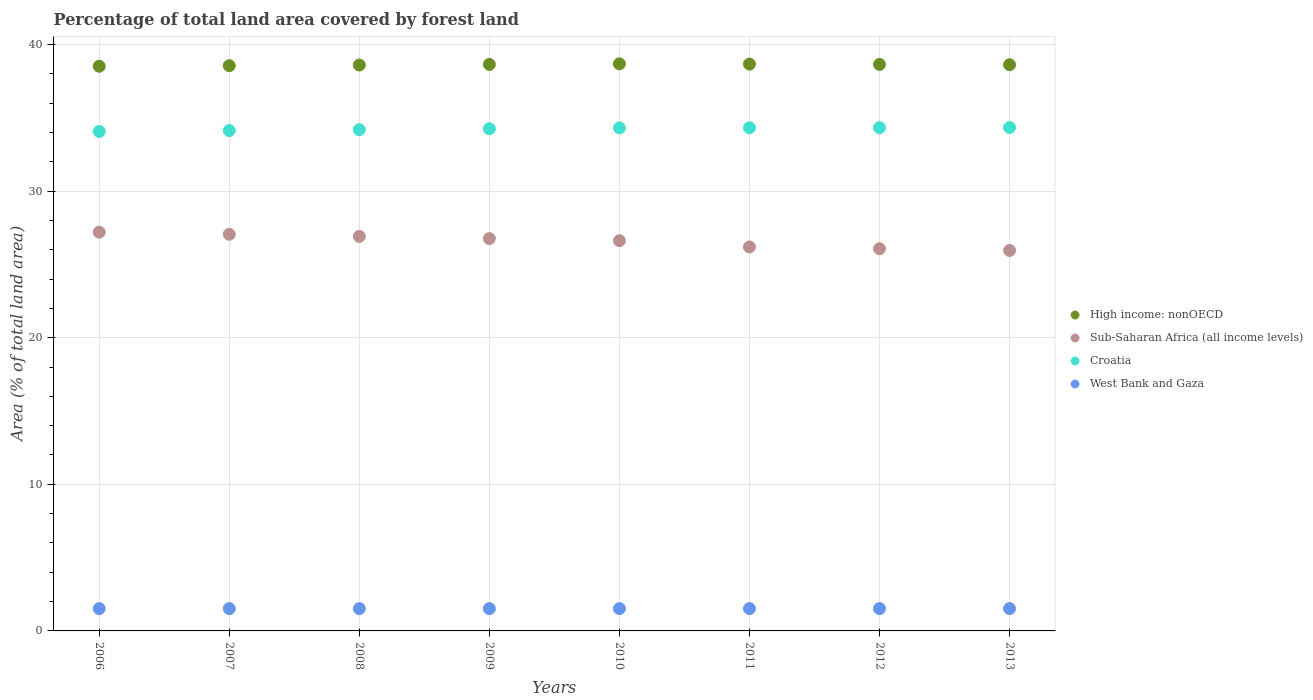How many different coloured dotlines are there?
Provide a short and direct response. 4. Is the number of dotlines equal to the number of legend labels?
Ensure brevity in your answer.  Yes. What is the percentage of forest land in West Bank and Gaza in 2010?
Provide a short and direct response. 1.52. Across all years, what is the maximum percentage of forest land in Sub-Saharan Africa (all income levels)?
Your answer should be compact. 27.2. Across all years, what is the minimum percentage of forest land in West Bank and Gaza?
Provide a succinct answer. 1.52. In which year was the percentage of forest land in West Bank and Gaza minimum?
Your response must be concise. 2006. What is the total percentage of forest land in Sub-Saharan Africa (all income levels) in the graph?
Your answer should be very brief. 212.74. What is the difference between the percentage of forest land in Sub-Saharan Africa (all income levels) in 2009 and that in 2013?
Make the answer very short. 0.81. What is the difference between the percentage of forest land in Croatia in 2011 and the percentage of forest land in Sub-Saharan Africa (all income levels) in 2013?
Provide a succinct answer. 8.37. What is the average percentage of forest land in West Bank and Gaza per year?
Provide a short and direct response. 1.52. In the year 2008, what is the difference between the percentage of forest land in West Bank and Gaza and percentage of forest land in Croatia?
Ensure brevity in your answer.  -32.67. In how many years, is the percentage of forest land in Sub-Saharan Africa (all income levels) greater than 28 %?
Offer a terse response. 0. What is the ratio of the percentage of forest land in High income: nonOECD in 2007 to that in 2013?
Your answer should be compact. 1. Is the difference between the percentage of forest land in West Bank and Gaza in 2009 and 2011 greater than the difference between the percentage of forest land in Croatia in 2009 and 2011?
Your response must be concise. Yes. What is the difference between the highest and the second highest percentage of forest land in Sub-Saharan Africa (all income levels)?
Your response must be concise. 0.15. What is the difference between the highest and the lowest percentage of forest land in High income: nonOECD?
Ensure brevity in your answer.  0.17. In how many years, is the percentage of forest land in Sub-Saharan Africa (all income levels) greater than the average percentage of forest land in Sub-Saharan Africa (all income levels) taken over all years?
Make the answer very short. 5. Is it the case that in every year, the sum of the percentage of forest land in Sub-Saharan Africa (all income levels) and percentage of forest land in Croatia  is greater than the sum of percentage of forest land in High income: nonOECD and percentage of forest land in West Bank and Gaza?
Your answer should be compact. No. Is it the case that in every year, the sum of the percentage of forest land in High income: nonOECD and percentage of forest land in West Bank and Gaza  is greater than the percentage of forest land in Croatia?
Your answer should be compact. Yes. Does the percentage of forest land in Sub-Saharan Africa (all income levels) monotonically increase over the years?
Make the answer very short. No. Is the percentage of forest land in Croatia strictly greater than the percentage of forest land in Sub-Saharan Africa (all income levels) over the years?
Make the answer very short. Yes. Is the percentage of forest land in Croatia strictly less than the percentage of forest land in Sub-Saharan Africa (all income levels) over the years?
Your answer should be very brief. No. What is the difference between two consecutive major ticks on the Y-axis?
Offer a very short reply. 10. Are the values on the major ticks of Y-axis written in scientific E-notation?
Your answer should be compact. No. Does the graph contain grids?
Provide a succinct answer. Yes. Where does the legend appear in the graph?
Your answer should be compact. Center right. How are the legend labels stacked?
Your answer should be very brief. Vertical. What is the title of the graph?
Your response must be concise. Percentage of total land area covered by forest land. What is the label or title of the X-axis?
Offer a very short reply. Years. What is the label or title of the Y-axis?
Your answer should be compact. Area (% of total land area). What is the Area (% of total land area) in High income: nonOECD in 2006?
Your answer should be compact. 38.51. What is the Area (% of total land area) in Sub-Saharan Africa (all income levels) in 2006?
Your answer should be compact. 27.2. What is the Area (% of total land area) of Croatia in 2006?
Make the answer very short. 34.07. What is the Area (% of total land area) in West Bank and Gaza in 2006?
Give a very brief answer. 1.52. What is the Area (% of total land area) of High income: nonOECD in 2007?
Your answer should be compact. 38.55. What is the Area (% of total land area) in Sub-Saharan Africa (all income levels) in 2007?
Keep it short and to the point. 27.05. What is the Area (% of total land area) of Croatia in 2007?
Your answer should be compact. 34.13. What is the Area (% of total land area) in West Bank and Gaza in 2007?
Give a very brief answer. 1.52. What is the Area (% of total land area) of High income: nonOECD in 2008?
Ensure brevity in your answer.  38.6. What is the Area (% of total land area) of Sub-Saharan Africa (all income levels) in 2008?
Your answer should be very brief. 26.91. What is the Area (% of total land area) in Croatia in 2008?
Give a very brief answer. 34.19. What is the Area (% of total land area) of West Bank and Gaza in 2008?
Keep it short and to the point. 1.52. What is the Area (% of total land area) in High income: nonOECD in 2009?
Ensure brevity in your answer.  38.64. What is the Area (% of total land area) in Sub-Saharan Africa (all income levels) in 2009?
Your response must be concise. 26.76. What is the Area (% of total land area) of Croatia in 2009?
Offer a very short reply. 34.25. What is the Area (% of total land area) in West Bank and Gaza in 2009?
Your response must be concise. 1.52. What is the Area (% of total land area) in High income: nonOECD in 2010?
Your answer should be compact. 38.68. What is the Area (% of total land area) of Sub-Saharan Africa (all income levels) in 2010?
Offer a very short reply. 26.62. What is the Area (% of total land area) of Croatia in 2010?
Offer a very short reply. 34.31. What is the Area (% of total land area) of West Bank and Gaza in 2010?
Offer a very short reply. 1.52. What is the Area (% of total land area) in High income: nonOECD in 2011?
Provide a succinct answer. 38.66. What is the Area (% of total land area) of Sub-Saharan Africa (all income levels) in 2011?
Ensure brevity in your answer.  26.19. What is the Area (% of total land area) of Croatia in 2011?
Provide a succinct answer. 34.32. What is the Area (% of total land area) of West Bank and Gaza in 2011?
Provide a short and direct response. 1.52. What is the Area (% of total land area) in High income: nonOECD in 2012?
Offer a very short reply. 38.64. What is the Area (% of total land area) in Sub-Saharan Africa (all income levels) in 2012?
Your response must be concise. 26.07. What is the Area (% of total land area) in Croatia in 2012?
Ensure brevity in your answer.  34.32. What is the Area (% of total land area) of West Bank and Gaza in 2012?
Your answer should be very brief. 1.52. What is the Area (% of total land area) of High income: nonOECD in 2013?
Provide a short and direct response. 38.62. What is the Area (% of total land area) of Sub-Saharan Africa (all income levels) in 2013?
Provide a short and direct response. 25.95. What is the Area (% of total land area) in Croatia in 2013?
Provide a short and direct response. 34.33. What is the Area (% of total land area) of West Bank and Gaza in 2013?
Keep it short and to the point. 1.52. Across all years, what is the maximum Area (% of total land area) of High income: nonOECD?
Give a very brief answer. 38.68. Across all years, what is the maximum Area (% of total land area) of Sub-Saharan Africa (all income levels)?
Your answer should be very brief. 27.2. Across all years, what is the maximum Area (% of total land area) of Croatia?
Your answer should be compact. 34.33. Across all years, what is the maximum Area (% of total land area) of West Bank and Gaza?
Offer a terse response. 1.52. Across all years, what is the minimum Area (% of total land area) in High income: nonOECD?
Offer a very short reply. 38.51. Across all years, what is the minimum Area (% of total land area) of Sub-Saharan Africa (all income levels)?
Give a very brief answer. 25.95. Across all years, what is the minimum Area (% of total land area) in Croatia?
Offer a terse response. 34.07. Across all years, what is the minimum Area (% of total land area) of West Bank and Gaza?
Keep it short and to the point. 1.52. What is the total Area (% of total land area) of High income: nonOECD in the graph?
Provide a short and direct response. 308.9. What is the total Area (% of total land area) in Sub-Saharan Africa (all income levels) in the graph?
Your answer should be compact. 212.74. What is the total Area (% of total land area) of Croatia in the graph?
Ensure brevity in your answer.  273.92. What is the total Area (% of total land area) of West Bank and Gaza in the graph?
Your answer should be very brief. 12.19. What is the difference between the Area (% of total land area) of High income: nonOECD in 2006 and that in 2007?
Ensure brevity in your answer.  -0.04. What is the difference between the Area (% of total land area) in Sub-Saharan Africa (all income levels) in 2006 and that in 2007?
Your response must be concise. 0.15. What is the difference between the Area (% of total land area) in Croatia in 2006 and that in 2007?
Your answer should be compact. -0.06. What is the difference between the Area (% of total land area) of West Bank and Gaza in 2006 and that in 2007?
Offer a terse response. 0. What is the difference between the Area (% of total land area) in High income: nonOECD in 2006 and that in 2008?
Give a very brief answer. -0.08. What is the difference between the Area (% of total land area) in Sub-Saharan Africa (all income levels) in 2006 and that in 2008?
Give a very brief answer. 0.29. What is the difference between the Area (% of total land area) of Croatia in 2006 and that in 2008?
Your answer should be very brief. -0.12. What is the difference between the Area (% of total land area) in High income: nonOECD in 2006 and that in 2009?
Keep it short and to the point. -0.13. What is the difference between the Area (% of total land area) in Sub-Saharan Africa (all income levels) in 2006 and that in 2009?
Ensure brevity in your answer.  0.44. What is the difference between the Area (% of total land area) in Croatia in 2006 and that in 2009?
Offer a terse response. -0.18. What is the difference between the Area (% of total land area) of West Bank and Gaza in 2006 and that in 2009?
Your response must be concise. 0. What is the difference between the Area (% of total land area) of High income: nonOECD in 2006 and that in 2010?
Provide a short and direct response. -0.17. What is the difference between the Area (% of total land area) in Sub-Saharan Africa (all income levels) in 2006 and that in 2010?
Keep it short and to the point. 0.58. What is the difference between the Area (% of total land area) of Croatia in 2006 and that in 2010?
Make the answer very short. -0.24. What is the difference between the Area (% of total land area) of West Bank and Gaza in 2006 and that in 2010?
Your response must be concise. 0. What is the difference between the Area (% of total land area) in High income: nonOECD in 2006 and that in 2011?
Provide a succinct answer. -0.15. What is the difference between the Area (% of total land area) of Croatia in 2006 and that in 2011?
Offer a terse response. -0.25. What is the difference between the Area (% of total land area) in High income: nonOECD in 2006 and that in 2012?
Offer a terse response. -0.13. What is the difference between the Area (% of total land area) in Sub-Saharan Africa (all income levels) in 2006 and that in 2012?
Offer a very short reply. 1.13. What is the difference between the Area (% of total land area) in Croatia in 2006 and that in 2012?
Offer a very short reply. -0.26. What is the difference between the Area (% of total land area) in West Bank and Gaza in 2006 and that in 2012?
Your response must be concise. 0. What is the difference between the Area (% of total land area) in High income: nonOECD in 2006 and that in 2013?
Your answer should be very brief. -0.11. What is the difference between the Area (% of total land area) of Sub-Saharan Africa (all income levels) in 2006 and that in 2013?
Your response must be concise. 1.25. What is the difference between the Area (% of total land area) in Croatia in 2006 and that in 2013?
Offer a terse response. -0.26. What is the difference between the Area (% of total land area) in West Bank and Gaza in 2006 and that in 2013?
Provide a short and direct response. 0. What is the difference between the Area (% of total land area) in High income: nonOECD in 2007 and that in 2008?
Give a very brief answer. -0.04. What is the difference between the Area (% of total land area) of Sub-Saharan Africa (all income levels) in 2007 and that in 2008?
Your answer should be compact. 0.15. What is the difference between the Area (% of total land area) in Croatia in 2007 and that in 2008?
Give a very brief answer. -0.06. What is the difference between the Area (% of total land area) in High income: nonOECD in 2007 and that in 2009?
Provide a succinct answer. -0.08. What is the difference between the Area (% of total land area) in Sub-Saharan Africa (all income levels) in 2007 and that in 2009?
Ensure brevity in your answer.  0.29. What is the difference between the Area (% of total land area) of Croatia in 2007 and that in 2009?
Offer a terse response. -0.12. What is the difference between the Area (% of total land area) of High income: nonOECD in 2007 and that in 2010?
Ensure brevity in your answer.  -0.13. What is the difference between the Area (% of total land area) in Sub-Saharan Africa (all income levels) in 2007 and that in 2010?
Provide a succinct answer. 0.44. What is the difference between the Area (% of total land area) in Croatia in 2007 and that in 2010?
Provide a short and direct response. -0.18. What is the difference between the Area (% of total land area) in High income: nonOECD in 2007 and that in 2011?
Offer a terse response. -0.11. What is the difference between the Area (% of total land area) in Sub-Saharan Africa (all income levels) in 2007 and that in 2011?
Your response must be concise. 0.86. What is the difference between the Area (% of total land area) of Croatia in 2007 and that in 2011?
Your response must be concise. -0.19. What is the difference between the Area (% of total land area) in West Bank and Gaza in 2007 and that in 2011?
Your answer should be compact. 0. What is the difference between the Area (% of total land area) of High income: nonOECD in 2007 and that in 2012?
Ensure brevity in your answer.  -0.08. What is the difference between the Area (% of total land area) in Sub-Saharan Africa (all income levels) in 2007 and that in 2012?
Your answer should be compact. 0.98. What is the difference between the Area (% of total land area) in Croatia in 2007 and that in 2012?
Ensure brevity in your answer.  -0.2. What is the difference between the Area (% of total land area) in High income: nonOECD in 2007 and that in 2013?
Your answer should be compact. -0.06. What is the difference between the Area (% of total land area) in Sub-Saharan Africa (all income levels) in 2007 and that in 2013?
Make the answer very short. 1.1. What is the difference between the Area (% of total land area) of Croatia in 2007 and that in 2013?
Your response must be concise. -0.2. What is the difference between the Area (% of total land area) of High income: nonOECD in 2008 and that in 2009?
Keep it short and to the point. -0.04. What is the difference between the Area (% of total land area) of Sub-Saharan Africa (all income levels) in 2008 and that in 2009?
Give a very brief answer. 0.15. What is the difference between the Area (% of total land area) in Croatia in 2008 and that in 2009?
Provide a short and direct response. -0.06. What is the difference between the Area (% of total land area) in West Bank and Gaza in 2008 and that in 2009?
Offer a terse response. 0. What is the difference between the Area (% of total land area) of High income: nonOECD in 2008 and that in 2010?
Provide a succinct answer. -0.08. What is the difference between the Area (% of total land area) of Sub-Saharan Africa (all income levels) in 2008 and that in 2010?
Make the answer very short. 0.29. What is the difference between the Area (% of total land area) in Croatia in 2008 and that in 2010?
Make the answer very short. -0.12. What is the difference between the Area (% of total land area) of High income: nonOECD in 2008 and that in 2011?
Offer a very short reply. -0.06. What is the difference between the Area (% of total land area) of Sub-Saharan Africa (all income levels) in 2008 and that in 2011?
Make the answer very short. 0.71. What is the difference between the Area (% of total land area) in Croatia in 2008 and that in 2011?
Provide a short and direct response. -0.13. What is the difference between the Area (% of total land area) in West Bank and Gaza in 2008 and that in 2011?
Offer a terse response. 0. What is the difference between the Area (% of total land area) of High income: nonOECD in 2008 and that in 2012?
Provide a succinct answer. -0.04. What is the difference between the Area (% of total land area) of Sub-Saharan Africa (all income levels) in 2008 and that in 2012?
Your response must be concise. 0.84. What is the difference between the Area (% of total land area) of Croatia in 2008 and that in 2012?
Offer a terse response. -0.14. What is the difference between the Area (% of total land area) in High income: nonOECD in 2008 and that in 2013?
Give a very brief answer. -0.02. What is the difference between the Area (% of total land area) in Sub-Saharan Africa (all income levels) in 2008 and that in 2013?
Offer a terse response. 0.96. What is the difference between the Area (% of total land area) in Croatia in 2008 and that in 2013?
Provide a short and direct response. -0.14. What is the difference between the Area (% of total land area) in West Bank and Gaza in 2008 and that in 2013?
Make the answer very short. 0. What is the difference between the Area (% of total land area) of High income: nonOECD in 2009 and that in 2010?
Your response must be concise. -0.04. What is the difference between the Area (% of total land area) of Sub-Saharan Africa (all income levels) in 2009 and that in 2010?
Keep it short and to the point. 0.15. What is the difference between the Area (% of total land area) of Croatia in 2009 and that in 2010?
Your answer should be compact. -0.06. What is the difference between the Area (% of total land area) of High income: nonOECD in 2009 and that in 2011?
Your answer should be compact. -0.02. What is the difference between the Area (% of total land area) in Sub-Saharan Africa (all income levels) in 2009 and that in 2011?
Provide a short and direct response. 0.57. What is the difference between the Area (% of total land area) in Croatia in 2009 and that in 2011?
Ensure brevity in your answer.  -0.07. What is the difference between the Area (% of total land area) in High income: nonOECD in 2009 and that in 2012?
Your response must be concise. -0. What is the difference between the Area (% of total land area) in Sub-Saharan Africa (all income levels) in 2009 and that in 2012?
Give a very brief answer. 0.69. What is the difference between the Area (% of total land area) in Croatia in 2009 and that in 2012?
Provide a succinct answer. -0.08. What is the difference between the Area (% of total land area) in High income: nonOECD in 2009 and that in 2013?
Give a very brief answer. 0.02. What is the difference between the Area (% of total land area) in Sub-Saharan Africa (all income levels) in 2009 and that in 2013?
Offer a very short reply. 0.81. What is the difference between the Area (% of total land area) in Croatia in 2009 and that in 2013?
Your answer should be compact. -0.08. What is the difference between the Area (% of total land area) of High income: nonOECD in 2010 and that in 2011?
Your response must be concise. 0.02. What is the difference between the Area (% of total land area) in Sub-Saharan Africa (all income levels) in 2010 and that in 2011?
Ensure brevity in your answer.  0.42. What is the difference between the Area (% of total land area) in Croatia in 2010 and that in 2011?
Make the answer very short. -0.01. What is the difference between the Area (% of total land area) of High income: nonOECD in 2010 and that in 2012?
Your answer should be compact. 0.04. What is the difference between the Area (% of total land area) in Sub-Saharan Africa (all income levels) in 2010 and that in 2012?
Your answer should be compact. 0.54. What is the difference between the Area (% of total land area) of Croatia in 2010 and that in 2012?
Give a very brief answer. -0.01. What is the difference between the Area (% of total land area) in High income: nonOECD in 2010 and that in 2013?
Offer a terse response. 0.06. What is the difference between the Area (% of total land area) in Sub-Saharan Africa (all income levels) in 2010 and that in 2013?
Provide a succinct answer. 0.66. What is the difference between the Area (% of total land area) in Croatia in 2010 and that in 2013?
Offer a very short reply. -0.02. What is the difference between the Area (% of total land area) of West Bank and Gaza in 2010 and that in 2013?
Your response must be concise. 0. What is the difference between the Area (% of total land area) in High income: nonOECD in 2011 and that in 2012?
Your answer should be very brief. 0.02. What is the difference between the Area (% of total land area) of Sub-Saharan Africa (all income levels) in 2011 and that in 2012?
Provide a succinct answer. 0.12. What is the difference between the Area (% of total land area) in Croatia in 2011 and that in 2012?
Your answer should be compact. -0.01. What is the difference between the Area (% of total land area) of High income: nonOECD in 2011 and that in 2013?
Provide a short and direct response. 0.04. What is the difference between the Area (% of total land area) of Sub-Saharan Africa (all income levels) in 2011 and that in 2013?
Give a very brief answer. 0.24. What is the difference between the Area (% of total land area) in Croatia in 2011 and that in 2013?
Give a very brief answer. -0.01. What is the difference between the Area (% of total land area) of High income: nonOECD in 2012 and that in 2013?
Your response must be concise. 0.02. What is the difference between the Area (% of total land area) of Sub-Saharan Africa (all income levels) in 2012 and that in 2013?
Ensure brevity in your answer.  0.12. What is the difference between the Area (% of total land area) of Croatia in 2012 and that in 2013?
Ensure brevity in your answer.  -0.01. What is the difference between the Area (% of total land area) of West Bank and Gaza in 2012 and that in 2013?
Make the answer very short. 0. What is the difference between the Area (% of total land area) in High income: nonOECD in 2006 and the Area (% of total land area) in Sub-Saharan Africa (all income levels) in 2007?
Provide a short and direct response. 11.46. What is the difference between the Area (% of total land area) in High income: nonOECD in 2006 and the Area (% of total land area) in Croatia in 2007?
Make the answer very short. 4.39. What is the difference between the Area (% of total land area) of High income: nonOECD in 2006 and the Area (% of total land area) of West Bank and Gaza in 2007?
Offer a very short reply. 36.99. What is the difference between the Area (% of total land area) of Sub-Saharan Africa (all income levels) in 2006 and the Area (% of total land area) of Croatia in 2007?
Offer a terse response. -6.93. What is the difference between the Area (% of total land area) in Sub-Saharan Africa (all income levels) in 2006 and the Area (% of total land area) in West Bank and Gaza in 2007?
Offer a terse response. 25.67. What is the difference between the Area (% of total land area) of Croatia in 2006 and the Area (% of total land area) of West Bank and Gaza in 2007?
Your answer should be very brief. 32.54. What is the difference between the Area (% of total land area) of High income: nonOECD in 2006 and the Area (% of total land area) of Sub-Saharan Africa (all income levels) in 2008?
Your response must be concise. 11.61. What is the difference between the Area (% of total land area) of High income: nonOECD in 2006 and the Area (% of total land area) of Croatia in 2008?
Your answer should be very brief. 4.32. What is the difference between the Area (% of total land area) of High income: nonOECD in 2006 and the Area (% of total land area) of West Bank and Gaza in 2008?
Offer a very short reply. 36.99. What is the difference between the Area (% of total land area) of Sub-Saharan Africa (all income levels) in 2006 and the Area (% of total land area) of Croatia in 2008?
Give a very brief answer. -6.99. What is the difference between the Area (% of total land area) in Sub-Saharan Africa (all income levels) in 2006 and the Area (% of total land area) in West Bank and Gaza in 2008?
Make the answer very short. 25.67. What is the difference between the Area (% of total land area) of Croatia in 2006 and the Area (% of total land area) of West Bank and Gaza in 2008?
Provide a succinct answer. 32.54. What is the difference between the Area (% of total land area) of High income: nonOECD in 2006 and the Area (% of total land area) of Sub-Saharan Africa (all income levels) in 2009?
Offer a very short reply. 11.75. What is the difference between the Area (% of total land area) in High income: nonOECD in 2006 and the Area (% of total land area) in Croatia in 2009?
Keep it short and to the point. 4.26. What is the difference between the Area (% of total land area) of High income: nonOECD in 2006 and the Area (% of total land area) of West Bank and Gaza in 2009?
Ensure brevity in your answer.  36.99. What is the difference between the Area (% of total land area) in Sub-Saharan Africa (all income levels) in 2006 and the Area (% of total land area) in Croatia in 2009?
Give a very brief answer. -7.05. What is the difference between the Area (% of total land area) in Sub-Saharan Africa (all income levels) in 2006 and the Area (% of total land area) in West Bank and Gaza in 2009?
Offer a very short reply. 25.67. What is the difference between the Area (% of total land area) in Croatia in 2006 and the Area (% of total land area) in West Bank and Gaza in 2009?
Provide a succinct answer. 32.54. What is the difference between the Area (% of total land area) of High income: nonOECD in 2006 and the Area (% of total land area) of Sub-Saharan Africa (all income levels) in 2010?
Your response must be concise. 11.9. What is the difference between the Area (% of total land area) in High income: nonOECD in 2006 and the Area (% of total land area) in Croatia in 2010?
Your response must be concise. 4.2. What is the difference between the Area (% of total land area) of High income: nonOECD in 2006 and the Area (% of total land area) of West Bank and Gaza in 2010?
Provide a short and direct response. 36.99. What is the difference between the Area (% of total land area) in Sub-Saharan Africa (all income levels) in 2006 and the Area (% of total land area) in Croatia in 2010?
Your response must be concise. -7.11. What is the difference between the Area (% of total land area) in Sub-Saharan Africa (all income levels) in 2006 and the Area (% of total land area) in West Bank and Gaza in 2010?
Provide a succinct answer. 25.67. What is the difference between the Area (% of total land area) in Croatia in 2006 and the Area (% of total land area) in West Bank and Gaza in 2010?
Provide a short and direct response. 32.54. What is the difference between the Area (% of total land area) in High income: nonOECD in 2006 and the Area (% of total land area) in Sub-Saharan Africa (all income levels) in 2011?
Give a very brief answer. 12.32. What is the difference between the Area (% of total land area) in High income: nonOECD in 2006 and the Area (% of total land area) in Croatia in 2011?
Your answer should be compact. 4.2. What is the difference between the Area (% of total land area) in High income: nonOECD in 2006 and the Area (% of total land area) in West Bank and Gaza in 2011?
Make the answer very short. 36.99. What is the difference between the Area (% of total land area) in Sub-Saharan Africa (all income levels) in 2006 and the Area (% of total land area) in Croatia in 2011?
Give a very brief answer. -7.12. What is the difference between the Area (% of total land area) of Sub-Saharan Africa (all income levels) in 2006 and the Area (% of total land area) of West Bank and Gaza in 2011?
Your answer should be very brief. 25.67. What is the difference between the Area (% of total land area) in Croatia in 2006 and the Area (% of total land area) in West Bank and Gaza in 2011?
Provide a succinct answer. 32.54. What is the difference between the Area (% of total land area) of High income: nonOECD in 2006 and the Area (% of total land area) of Sub-Saharan Africa (all income levels) in 2012?
Keep it short and to the point. 12.44. What is the difference between the Area (% of total land area) of High income: nonOECD in 2006 and the Area (% of total land area) of Croatia in 2012?
Ensure brevity in your answer.  4.19. What is the difference between the Area (% of total land area) in High income: nonOECD in 2006 and the Area (% of total land area) in West Bank and Gaza in 2012?
Your response must be concise. 36.99. What is the difference between the Area (% of total land area) in Sub-Saharan Africa (all income levels) in 2006 and the Area (% of total land area) in Croatia in 2012?
Offer a very short reply. -7.13. What is the difference between the Area (% of total land area) in Sub-Saharan Africa (all income levels) in 2006 and the Area (% of total land area) in West Bank and Gaza in 2012?
Ensure brevity in your answer.  25.67. What is the difference between the Area (% of total land area) in Croatia in 2006 and the Area (% of total land area) in West Bank and Gaza in 2012?
Offer a terse response. 32.54. What is the difference between the Area (% of total land area) in High income: nonOECD in 2006 and the Area (% of total land area) in Sub-Saharan Africa (all income levels) in 2013?
Ensure brevity in your answer.  12.56. What is the difference between the Area (% of total land area) in High income: nonOECD in 2006 and the Area (% of total land area) in Croatia in 2013?
Ensure brevity in your answer.  4.18. What is the difference between the Area (% of total land area) in High income: nonOECD in 2006 and the Area (% of total land area) in West Bank and Gaza in 2013?
Offer a very short reply. 36.99. What is the difference between the Area (% of total land area) in Sub-Saharan Africa (all income levels) in 2006 and the Area (% of total land area) in Croatia in 2013?
Your answer should be compact. -7.14. What is the difference between the Area (% of total land area) in Sub-Saharan Africa (all income levels) in 2006 and the Area (% of total land area) in West Bank and Gaza in 2013?
Make the answer very short. 25.67. What is the difference between the Area (% of total land area) in Croatia in 2006 and the Area (% of total land area) in West Bank and Gaza in 2013?
Offer a terse response. 32.54. What is the difference between the Area (% of total land area) of High income: nonOECD in 2007 and the Area (% of total land area) of Sub-Saharan Africa (all income levels) in 2008?
Your answer should be very brief. 11.65. What is the difference between the Area (% of total land area) of High income: nonOECD in 2007 and the Area (% of total land area) of Croatia in 2008?
Your answer should be compact. 4.37. What is the difference between the Area (% of total land area) in High income: nonOECD in 2007 and the Area (% of total land area) in West Bank and Gaza in 2008?
Provide a succinct answer. 37.03. What is the difference between the Area (% of total land area) of Sub-Saharan Africa (all income levels) in 2007 and the Area (% of total land area) of Croatia in 2008?
Make the answer very short. -7.14. What is the difference between the Area (% of total land area) of Sub-Saharan Africa (all income levels) in 2007 and the Area (% of total land area) of West Bank and Gaza in 2008?
Your response must be concise. 25.53. What is the difference between the Area (% of total land area) in Croatia in 2007 and the Area (% of total land area) in West Bank and Gaza in 2008?
Ensure brevity in your answer.  32.6. What is the difference between the Area (% of total land area) in High income: nonOECD in 2007 and the Area (% of total land area) in Sub-Saharan Africa (all income levels) in 2009?
Your answer should be very brief. 11.79. What is the difference between the Area (% of total land area) in High income: nonOECD in 2007 and the Area (% of total land area) in Croatia in 2009?
Offer a very short reply. 4.31. What is the difference between the Area (% of total land area) in High income: nonOECD in 2007 and the Area (% of total land area) in West Bank and Gaza in 2009?
Make the answer very short. 37.03. What is the difference between the Area (% of total land area) of Sub-Saharan Africa (all income levels) in 2007 and the Area (% of total land area) of Croatia in 2009?
Your response must be concise. -7.2. What is the difference between the Area (% of total land area) in Sub-Saharan Africa (all income levels) in 2007 and the Area (% of total land area) in West Bank and Gaza in 2009?
Your response must be concise. 25.53. What is the difference between the Area (% of total land area) of Croatia in 2007 and the Area (% of total land area) of West Bank and Gaza in 2009?
Your answer should be compact. 32.6. What is the difference between the Area (% of total land area) in High income: nonOECD in 2007 and the Area (% of total land area) in Sub-Saharan Africa (all income levels) in 2010?
Provide a short and direct response. 11.94. What is the difference between the Area (% of total land area) in High income: nonOECD in 2007 and the Area (% of total land area) in Croatia in 2010?
Your response must be concise. 4.24. What is the difference between the Area (% of total land area) of High income: nonOECD in 2007 and the Area (% of total land area) of West Bank and Gaza in 2010?
Your answer should be very brief. 37.03. What is the difference between the Area (% of total land area) of Sub-Saharan Africa (all income levels) in 2007 and the Area (% of total land area) of Croatia in 2010?
Offer a terse response. -7.26. What is the difference between the Area (% of total land area) of Sub-Saharan Africa (all income levels) in 2007 and the Area (% of total land area) of West Bank and Gaza in 2010?
Offer a very short reply. 25.53. What is the difference between the Area (% of total land area) in Croatia in 2007 and the Area (% of total land area) in West Bank and Gaza in 2010?
Offer a very short reply. 32.6. What is the difference between the Area (% of total land area) of High income: nonOECD in 2007 and the Area (% of total land area) of Sub-Saharan Africa (all income levels) in 2011?
Ensure brevity in your answer.  12.36. What is the difference between the Area (% of total land area) in High income: nonOECD in 2007 and the Area (% of total land area) in Croatia in 2011?
Your answer should be compact. 4.24. What is the difference between the Area (% of total land area) in High income: nonOECD in 2007 and the Area (% of total land area) in West Bank and Gaza in 2011?
Make the answer very short. 37.03. What is the difference between the Area (% of total land area) in Sub-Saharan Africa (all income levels) in 2007 and the Area (% of total land area) in Croatia in 2011?
Give a very brief answer. -7.27. What is the difference between the Area (% of total land area) of Sub-Saharan Africa (all income levels) in 2007 and the Area (% of total land area) of West Bank and Gaza in 2011?
Your answer should be very brief. 25.53. What is the difference between the Area (% of total land area) of Croatia in 2007 and the Area (% of total land area) of West Bank and Gaza in 2011?
Offer a terse response. 32.6. What is the difference between the Area (% of total land area) in High income: nonOECD in 2007 and the Area (% of total land area) in Sub-Saharan Africa (all income levels) in 2012?
Ensure brevity in your answer.  12.48. What is the difference between the Area (% of total land area) of High income: nonOECD in 2007 and the Area (% of total land area) of Croatia in 2012?
Offer a very short reply. 4.23. What is the difference between the Area (% of total land area) in High income: nonOECD in 2007 and the Area (% of total land area) in West Bank and Gaza in 2012?
Your response must be concise. 37.03. What is the difference between the Area (% of total land area) in Sub-Saharan Africa (all income levels) in 2007 and the Area (% of total land area) in Croatia in 2012?
Make the answer very short. -7.27. What is the difference between the Area (% of total land area) in Sub-Saharan Africa (all income levels) in 2007 and the Area (% of total land area) in West Bank and Gaza in 2012?
Ensure brevity in your answer.  25.53. What is the difference between the Area (% of total land area) of Croatia in 2007 and the Area (% of total land area) of West Bank and Gaza in 2012?
Provide a short and direct response. 32.6. What is the difference between the Area (% of total land area) in High income: nonOECD in 2007 and the Area (% of total land area) in Sub-Saharan Africa (all income levels) in 2013?
Make the answer very short. 12.6. What is the difference between the Area (% of total land area) of High income: nonOECD in 2007 and the Area (% of total land area) of Croatia in 2013?
Provide a succinct answer. 4.22. What is the difference between the Area (% of total land area) in High income: nonOECD in 2007 and the Area (% of total land area) in West Bank and Gaza in 2013?
Ensure brevity in your answer.  37.03. What is the difference between the Area (% of total land area) of Sub-Saharan Africa (all income levels) in 2007 and the Area (% of total land area) of Croatia in 2013?
Keep it short and to the point. -7.28. What is the difference between the Area (% of total land area) in Sub-Saharan Africa (all income levels) in 2007 and the Area (% of total land area) in West Bank and Gaza in 2013?
Your answer should be very brief. 25.53. What is the difference between the Area (% of total land area) in Croatia in 2007 and the Area (% of total land area) in West Bank and Gaza in 2013?
Ensure brevity in your answer.  32.6. What is the difference between the Area (% of total land area) of High income: nonOECD in 2008 and the Area (% of total land area) of Sub-Saharan Africa (all income levels) in 2009?
Provide a succinct answer. 11.84. What is the difference between the Area (% of total land area) of High income: nonOECD in 2008 and the Area (% of total land area) of Croatia in 2009?
Give a very brief answer. 4.35. What is the difference between the Area (% of total land area) of High income: nonOECD in 2008 and the Area (% of total land area) of West Bank and Gaza in 2009?
Offer a terse response. 37.07. What is the difference between the Area (% of total land area) of Sub-Saharan Africa (all income levels) in 2008 and the Area (% of total land area) of Croatia in 2009?
Your answer should be compact. -7.34. What is the difference between the Area (% of total land area) in Sub-Saharan Africa (all income levels) in 2008 and the Area (% of total land area) in West Bank and Gaza in 2009?
Provide a short and direct response. 25.38. What is the difference between the Area (% of total land area) in Croatia in 2008 and the Area (% of total land area) in West Bank and Gaza in 2009?
Offer a very short reply. 32.67. What is the difference between the Area (% of total land area) in High income: nonOECD in 2008 and the Area (% of total land area) in Sub-Saharan Africa (all income levels) in 2010?
Your answer should be very brief. 11.98. What is the difference between the Area (% of total land area) in High income: nonOECD in 2008 and the Area (% of total land area) in Croatia in 2010?
Your answer should be compact. 4.29. What is the difference between the Area (% of total land area) in High income: nonOECD in 2008 and the Area (% of total land area) in West Bank and Gaza in 2010?
Your answer should be compact. 37.07. What is the difference between the Area (% of total land area) in Sub-Saharan Africa (all income levels) in 2008 and the Area (% of total land area) in Croatia in 2010?
Your response must be concise. -7.4. What is the difference between the Area (% of total land area) in Sub-Saharan Africa (all income levels) in 2008 and the Area (% of total land area) in West Bank and Gaza in 2010?
Offer a very short reply. 25.38. What is the difference between the Area (% of total land area) of Croatia in 2008 and the Area (% of total land area) of West Bank and Gaza in 2010?
Provide a succinct answer. 32.67. What is the difference between the Area (% of total land area) in High income: nonOECD in 2008 and the Area (% of total land area) in Sub-Saharan Africa (all income levels) in 2011?
Provide a short and direct response. 12.41. What is the difference between the Area (% of total land area) in High income: nonOECD in 2008 and the Area (% of total land area) in Croatia in 2011?
Your answer should be compact. 4.28. What is the difference between the Area (% of total land area) of High income: nonOECD in 2008 and the Area (% of total land area) of West Bank and Gaza in 2011?
Ensure brevity in your answer.  37.07. What is the difference between the Area (% of total land area) of Sub-Saharan Africa (all income levels) in 2008 and the Area (% of total land area) of Croatia in 2011?
Ensure brevity in your answer.  -7.41. What is the difference between the Area (% of total land area) in Sub-Saharan Africa (all income levels) in 2008 and the Area (% of total land area) in West Bank and Gaza in 2011?
Provide a short and direct response. 25.38. What is the difference between the Area (% of total land area) in Croatia in 2008 and the Area (% of total land area) in West Bank and Gaza in 2011?
Make the answer very short. 32.67. What is the difference between the Area (% of total land area) of High income: nonOECD in 2008 and the Area (% of total land area) of Sub-Saharan Africa (all income levels) in 2012?
Keep it short and to the point. 12.53. What is the difference between the Area (% of total land area) in High income: nonOECD in 2008 and the Area (% of total land area) in Croatia in 2012?
Offer a terse response. 4.27. What is the difference between the Area (% of total land area) in High income: nonOECD in 2008 and the Area (% of total land area) in West Bank and Gaza in 2012?
Offer a very short reply. 37.07. What is the difference between the Area (% of total land area) in Sub-Saharan Africa (all income levels) in 2008 and the Area (% of total land area) in Croatia in 2012?
Offer a very short reply. -7.42. What is the difference between the Area (% of total land area) in Sub-Saharan Africa (all income levels) in 2008 and the Area (% of total land area) in West Bank and Gaza in 2012?
Make the answer very short. 25.38. What is the difference between the Area (% of total land area) in Croatia in 2008 and the Area (% of total land area) in West Bank and Gaza in 2012?
Provide a succinct answer. 32.67. What is the difference between the Area (% of total land area) in High income: nonOECD in 2008 and the Area (% of total land area) in Sub-Saharan Africa (all income levels) in 2013?
Your answer should be very brief. 12.65. What is the difference between the Area (% of total land area) in High income: nonOECD in 2008 and the Area (% of total land area) in Croatia in 2013?
Provide a short and direct response. 4.27. What is the difference between the Area (% of total land area) in High income: nonOECD in 2008 and the Area (% of total land area) in West Bank and Gaza in 2013?
Offer a terse response. 37.07. What is the difference between the Area (% of total land area) of Sub-Saharan Africa (all income levels) in 2008 and the Area (% of total land area) of Croatia in 2013?
Your answer should be compact. -7.43. What is the difference between the Area (% of total land area) of Sub-Saharan Africa (all income levels) in 2008 and the Area (% of total land area) of West Bank and Gaza in 2013?
Ensure brevity in your answer.  25.38. What is the difference between the Area (% of total land area) of Croatia in 2008 and the Area (% of total land area) of West Bank and Gaza in 2013?
Offer a terse response. 32.67. What is the difference between the Area (% of total land area) in High income: nonOECD in 2009 and the Area (% of total land area) in Sub-Saharan Africa (all income levels) in 2010?
Keep it short and to the point. 12.02. What is the difference between the Area (% of total land area) in High income: nonOECD in 2009 and the Area (% of total land area) in Croatia in 2010?
Your answer should be compact. 4.33. What is the difference between the Area (% of total land area) of High income: nonOECD in 2009 and the Area (% of total land area) of West Bank and Gaza in 2010?
Offer a very short reply. 37.12. What is the difference between the Area (% of total land area) in Sub-Saharan Africa (all income levels) in 2009 and the Area (% of total land area) in Croatia in 2010?
Provide a succinct answer. -7.55. What is the difference between the Area (% of total land area) in Sub-Saharan Africa (all income levels) in 2009 and the Area (% of total land area) in West Bank and Gaza in 2010?
Ensure brevity in your answer.  25.24. What is the difference between the Area (% of total land area) of Croatia in 2009 and the Area (% of total land area) of West Bank and Gaza in 2010?
Provide a succinct answer. 32.73. What is the difference between the Area (% of total land area) of High income: nonOECD in 2009 and the Area (% of total land area) of Sub-Saharan Africa (all income levels) in 2011?
Your response must be concise. 12.45. What is the difference between the Area (% of total land area) in High income: nonOECD in 2009 and the Area (% of total land area) in Croatia in 2011?
Offer a terse response. 4.32. What is the difference between the Area (% of total land area) of High income: nonOECD in 2009 and the Area (% of total land area) of West Bank and Gaza in 2011?
Keep it short and to the point. 37.12. What is the difference between the Area (% of total land area) of Sub-Saharan Africa (all income levels) in 2009 and the Area (% of total land area) of Croatia in 2011?
Offer a very short reply. -7.56. What is the difference between the Area (% of total land area) in Sub-Saharan Africa (all income levels) in 2009 and the Area (% of total land area) in West Bank and Gaza in 2011?
Offer a terse response. 25.24. What is the difference between the Area (% of total land area) of Croatia in 2009 and the Area (% of total land area) of West Bank and Gaza in 2011?
Your response must be concise. 32.73. What is the difference between the Area (% of total land area) of High income: nonOECD in 2009 and the Area (% of total land area) of Sub-Saharan Africa (all income levels) in 2012?
Ensure brevity in your answer.  12.57. What is the difference between the Area (% of total land area) in High income: nonOECD in 2009 and the Area (% of total land area) in Croatia in 2012?
Your response must be concise. 4.31. What is the difference between the Area (% of total land area) in High income: nonOECD in 2009 and the Area (% of total land area) in West Bank and Gaza in 2012?
Provide a succinct answer. 37.12. What is the difference between the Area (% of total land area) of Sub-Saharan Africa (all income levels) in 2009 and the Area (% of total land area) of Croatia in 2012?
Offer a very short reply. -7.56. What is the difference between the Area (% of total land area) in Sub-Saharan Africa (all income levels) in 2009 and the Area (% of total land area) in West Bank and Gaza in 2012?
Offer a terse response. 25.24. What is the difference between the Area (% of total land area) in Croatia in 2009 and the Area (% of total land area) in West Bank and Gaza in 2012?
Ensure brevity in your answer.  32.73. What is the difference between the Area (% of total land area) of High income: nonOECD in 2009 and the Area (% of total land area) of Sub-Saharan Africa (all income levels) in 2013?
Your answer should be very brief. 12.69. What is the difference between the Area (% of total land area) of High income: nonOECD in 2009 and the Area (% of total land area) of Croatia in 2013?
Give a very brief answer. 4.31. What is the difference between the Area (% of total land area) in High income: nonOECD in 2009 and the Area (% of total land area) in West Bank and Gaza in 2013?
Offer a terse response. 37.12. What is the difference between the Area (% of total land area) of Sub-Saharan Africa (all income levels) in 2009 and the Area (% of total land area) of Croatia in 2013?
Offer a very short reply. -7.57. What is the difference between the Area (% of total land area) in Sub-Saharan Africa (all income levels) in 2009 and the Area (% of total land area) in West Bank and Gaza in 2013?
Your response must be concise. 25.24. What is the difference between the Area (% of total land area) in Croatia in 2009 and the Area (% of total land area) in West Bank and Gaza in 2013?
Keep it short and to the point. 32.73. What is the difference between the Area (% of total land area) in High income: nonOECD in 2010 and the Area (% of total land area) in Sub-Saharan Africa (all income levels) in 2011?
Your answer should be very brief. 12.49. What is the difference between the Area (% of total land area) in High income: nonOECD in 2010 and the Area (% of total land area) in Croatia in 2011?
Provide a short and direct response. 4.36. What is the difference between the Area (% of total land area) of High income: nonOECD in 2010 and the Area (% of total land area) of West Bank and Gaza in 2011?
Your answer should be compact. 37.16. What is the difference between the Area (% of total land area) of Sub-Saharan Africa (all income levels) in 2010 and the Area (% of total land area) of Croatia in 2011?
Ensure brevity in your answer.  -7.7. What is the difference between the Area (% of total land area) of Sub-Saharan Africa (all income levels) in 2010 and the Area (% of total land area) of West Bank and Gaza in 2011?
Offer a terse response. 25.09. What is the difference between the Area (% of total land area) of Croatia in 2010 and the Area (% of total land area) of West Bank and Gaza in 2011?
Keep it short and to the point. 32.79. What is the difference between the Area (% of total land area) in High income: nonOECD in 2010 and the Area (% of total land area) in Sub-Saharan Africa (all income levels) in 2012?
Provide a succinct answer. 12.61. What is the difference between the Area (% of total land area) of High income: nonOECD in 2010 and the Area (% of total land area) of Croatia in 2012?
Your response must be concise. 4.36. What is the difference between the Area (% of total land area) of High income: nonOECD in 2010 and the Area (% of total land area) of West Bank and Gaza in 2012?
Provide a succinct answer. 37.16. What is the difference between the Area (% of total land area) of Sub-Saharan Africa (all income levels) in 2010 and the Area (% of total land area) of Croatia in 2012?
Offer a very short reply. -7.71. What is the difference between the Area (% of total land area) in Sub-Saharan Africa (all income levels) in 2010 and the Area (% of total land area) in West Bank and Gaza in 2012?
Provide a short and direct response. 25.09. What is the difference between the Area (% of total land area) in Croatia in 2010 and the Area (% of total land area) in West Bank and Gaza in 2012?
Provide a succinct answer. 32.79. What is the difference between the Area (% of total land area) of High income: nonOECD in 2010 and the Area (% of total land area) of Sub-Saharan Africa (all income levels) in 2013?
Give a very brief answer. 12.73. What is the difference between the Area (% of total land area) of High income: nonOECD in 2010 and the Area (% of total land area) of Croatia in 2013?
Your answer should be very brief. 4.35. What is the difference between the Area (% of total land area) of High income: nonOECD in 2010 and the Area (% of total land area) of West Bank and Gaza in 2013?
Offer a very short reply. 37.16. What is the difference between the Area (% of total land area) of Sub-Saharan Africa (all income levels) in 2010 and the Area (% of total land area) of Croatia in 2013?
Your answer should be very brief. -7.72. What is the difference between the Area (% of total land area) of Sub-Saharan Africa (all income levels) in 2010 and the Area (% of total land area) of West Bank and Gaza in 2013?
Ensure brevity in your answer.  25.09. What is the difference between the Area (% of total land area) of Croatia in 2010 and the Area (% of total land area) of West Bank and Gaza in 2013?
Keep it short and to the point. 32.79. What is the difference between the Area (% of total land area) of High income: nonOECD in 2011 and the Area (% of total land area) of Sub-Saharan Africa (all income levels) in 2012?
Ensure brevity in your answer.  12.59. What is the difference between the Area (% of total land area) in High income: nonOECD in 2011 and the Area (% of total land area) in Croatia in 2012?
Your answer should be compact. 4.34. What is the difference between the Area (% of total land area) of High income: nonOECD in 2011 and the Area (% of total land area) of West Bank and Gaza in 2012?
Give a very brief answer. 37.14. What is the difference between the Area (% of total land area) in Sub-Saharan Africa (all income levels) in 2011 and the Area (% of total land area) in Croatia in 2012?
Offer a very short reply. -8.13. What is the difference between the Area (% of total land area) of Sub-Saharan Africa (all income levels) in 2011 and the Area (% of total land area) of West Bank and Gaza in 2012?
Give a very brief answer. 24.67. What is the difference between the Area (% of total land area) of Croatia in 2011 and the Area (% of total land area) of West Bank and Gaza in 2012?
Provide a short and direct response. 32.79. What is the difference between the Area (% of total land area) of High income: nonOECD in 2011 and the Area (% of total land area) of Sub-Saharan Africa (all income levels) in 2013?
Offer a terse response. 12.71. What is the difference between the Area (% of total land area) of High income: nonOECD in 2011 and the Area (% of total land area) of Croatia in 2013?
Give a very brief answer. 4.33. What is the difference between the Area (% of total land area) of High income: nonOECD in 2011 and the Area (% of total land area) of West Bank and Gaza in 2013?
Provide a short and direct response. 37.14. What is the difference between the Area (% of total land area) of Sub-Saharan Africa (all income levels) in 2011 and the Area (% of total land area) of Croatia in 2013?
Your response must be concise. -8.14. What is the difference between the Area (% of total land area) of Sub-Saharan Africa (all income levels) in 2011 and the Area (% of total land area) of West Bank and Gaza in 2013?
Provide a short and direct response. 24.67. What is the difference between the Area (% of total land area) in Croatia in 2011 and the Area (% of total land area) in West Bank and Gaza in 2013?
Make the answer very short. 32.79. What is the difference between the Area (% of total land area) in High income: nonOECD in 2012 and the Area (% of total land area) in Sub-Saharan Africa (all income levels) in 2013?
Keep it short and to the point. 12.69. What is the difference between the Area (% of total land area) in High income: nonOECD in 2012 and the Area (% of total land area) in Croatia in 2013?
Your response must be concise. 4.31. What is the difference between the Area (% of total land area) of High income: nonOECD in 2012 and the Area (% of total land area) of West Bank and Gaza in 2013?
Offer a terse response. 37.12. What is the difference between the Area (% of total land area) of Sub-Saharan Africa (all income levels) in 2012 and the Area (% of total land area) of Croatia in 2013?
Ensure brevity in your answer.  -8.26. What is the difference between the Area (% of total land area) of Sub-Saharan Africa (all income levels) in 2012 and the Area (% of total land area) of West Bank and Gaza in 2013?
Give a very brief answer. 24.55. What is the difference between the Area (% of total land area) in Croatia in 2012 and the Area (% of total land area) in West Bank and Gaza in 2013?
Keep it short and to the point. 32.8. What is the average Area (% of total land area) in High income: nonOECD per year?
Give a very brief answer. 38.61. What is the average Area (% of total land area) of Sub-Saharan Africa (all income levels) per year?
Your answer should be very brief. 26.59. What is the average Area (% of total land area) in Croatia per year?
Give a very brief answer. 34.24. What is the average Area (% of total land area) in West Bank and Gaza per year?
Your answer should be compact. 1.52. In the year 2006, what is the difference between the Area (% of total land area) of High income: nonOECD and Area (% of total land area) of Sub-Saharan Africa (all income levels)?
Your response must be concise. 11.32. In the year 2006, what is the difference between the Area (% of total land area) of High income: nonOECD and Area (% of total land area) of Croatia?
Make the answer very short. 4.45. In the year 2006, what is the difference between the Area (% of total land area) of High income: nonOECD and Area (% of total land area) of West Bank and Gaza?
Provide a succinct answer. 36.99. In the year 2006, what is the difference between the Area (% of total land area) of Sub-Saharan Africa (all income levels) and Area (% of total land area) of Croatia?
Keep it short and to the point. -6.87. In the year 2006, what is the difference between the Area (% of total land area) of Sub-Saharan Africa (all income levels) and Area (% of total land area) of West Bank and Gaza?
Offer a very short reply. 25.67. In the year 2006, what is the difference between the Area (% of total land area) of Croatia and Area (% of total land area) of West Bank and Gaza?
Give a very brief answer. 32.54. In the year 2007, what is the difference between the Area (% of total land area) in High income: nonOECD and Area (% of total land area) in Sub-Saharan Africa (all income levels)?
Ensure brevity in your answer.  11.5. In the year 2007, what is the difference between the Area (% of total land area) of High income: nonOECD and Area (% of total land area) of Croatia?
Your answer should be very brief. 4.43. In the year 2007, what is the difference between the Area (% of total land area) in High income: nonOECD and Area (% of total land area) in West Bank and Gaza?
Make the answer very short. 37.03. In the year 2007, what is the difference between the Area (% of total land area) in Sub-Saharan Africa (all income levels) and Area (% of total land area) in Croatia?
Ensure brevity in your answer.  -7.08. In the year 2007, what is the difference between the Area (% of total land area) in Sub-Saharan Africa (all income levels) and Area (% of total land area) in West Bank and Gaza?
Offer a very short reply. 25.53. In the year 2007, what is the difference between the Area (% of total land area) of Croatia and Area (% of total land area) of West Bank and Gaza?
Offer a very short reply. 32.6. In the year 2008, what is the difference between the Area (% of total land area) in High income: nonOECD and Area (% of total land area) in Sub-Saharan Africa (all income levels)?
Offer a terse response. 11.69. In the year 2008, what is the difference between the Area (% of total land area) in High income: nonOECD and Area (% of total land area) in Croatia?
Ensure brevity in your answer.  4.41. In the year 2008, what is the difference between the Area (% of total land area) in High income: nonOECD and Area (% of total land area) in West Bank and Gaza?
Offer a terse response. 37.07. In the year 2008, what is the difference between the Area (% of total land area) of Sub-Saharan Africa (all income levels) and Area (% of total land area) of Croatia?
Provide a short and direct response. -7.28. In the year 2008, what is the difference between the Area (% of total land area) of Sub-Saharan Africa (all income levels) and Area (% of total land area) of West Bank and Gaza?
Ensure brevity in your answer.  25.38. In the year 2008, what is the difference between the Area (% of total land area) of Croatia and Area (% of total land area) of West Bank and Gaza?
Give a very brief answer. 32.67. In the year 2009, what is the difference between the Area (% of total land area) in High income: nonOECD and Area (% of total land area) in Sub-Saharan Africa (all income levels)?
Give a very brief answer. 11.88. In the year 2009, what is the difference between the Area (% of total land area) of High income: nonOECD and Area (% of total land area) of Croatia?
Offer a very short reply. 4.39. In the year 2009, what is the difference between the Area (% of total land area) in High income: nonOECD and Area (% of total land area) in West Bank and Gaza?
Provide a short and direct response. 37.12. In the year 2009, what is the difference between the Area (% of total land area) of Sub-Saharan Africa (all income levels) and Area (% of total land area) of Croatia?
Keep it short and to the point. -7.49. In the year 2009, what is the difference between the Area (% of total land area) of Sub-Saharan Africa (all income levels) and Area (% of total land area) of West Bank and Gaza?
Your response must be concise. 25.24. In the year 2009, what is the difference between the Area (% of total land area) of Croatia and Area (% of total land area) of West Bank and Gaza?
Your answer should be very brief. 32.73. In the year 2010, what is the difference between the Area (% of total land area) of High income: nonOECD and Area (% of total land area) of Sub-Saharan Africa (all income levels)?
Offer a terse response. 12.06. In the year 2010, what is the difference between the Area (% of total land area) of High income: nonOECD and Area (% of total land area) of Croatia?
Ensure brevity in your answer.  4.37. In the year 2010, what is the difference between the Area (% of total land area) in High income: nonOECD and Area (% of total land area) in West Bank and Gaza?
Your response must be concise. 37.16. In the year 2010, what is the difference between the Area (% of total land area) of Sub-Saharan Africa (all income levels) and Area (% of total land area) of Croatia?
Your answer should be very brief. -7.69. In the year 2010, what is the difference between the Area (% of total land area) in Sub-Saharan Africa (all income levels) and Area (% of total land area) in West Bank and Gaza?
Make the answer very short. 25.09. In the year 2010, what is the difference between the Area (% of total land area) of Croatia and Area (% of total land area) of West Bank and Gaza?
Your answer should be compact. 32.79. In the year 2011, what is the difference between the Area (% of total land area) of High income: nonOECD and Area (% of total land area) of Sub-Saharan Africa (all income levels)?
Your answer should be very brief. 12.47. In the year 2011, what is the difference between the Area (% of total land area) in High income: nonOECD and Area (% of total land area) in Croatia?
Offer a very short reply. 4.34. In the year 2011, what is the difference between the Area (% of total land area) of High income: nonOECD and Area (% of total land area) of West Bank and Gaza?
Provide a short and direct response. 37.14. In the year 2011, what is the difference between the Area (% of total land area) of Sub-Saharan Africa (all income levels) and Area (% of total land area) of Croatia?
Provide a succinct answer. -8.13. In the year 2011, what is the difference between the Area (% of total land area) in Sub-Saharan Africa (all income levels) and Area (% of total land area) in West Bank and Gaza?
Your answer should be very brief. 24.67. In the year 2011, what is the difference between the Area (% of total land area) in Croatia and Area (% of total land area) in West Bank and Gaza?
Your response must be concise. 32.79. In the year 2012, what is the difference between the Area (% of total land area) in High income: nonOECD and Area (% of total land area) in Sub-Saharan Africa (all income levels)?
Give a very brief answer. 12.57. In the year 2012, what is the difference between the Area (% of total land area) of High income: nonOECD and Area (% of total land area) of Croatia?
Provide a short and direct response. 4.31. In the year 2012, what is the difference between the Area (% of total land area) of High income: nonOECD and Area (% of total land area) of West Bank and Gaza?
Give a very brief answer. 37.12. In the year 2012, what is the difference between the Area (% of total land area) in Sub-Saharan Africa (all income levels) and Area (% of total land area) in Croatia?
Ensure brevity in your answer.  -8.25. In the year 2012, what is the difference between the Area (% of total land area) of Sub-Saharan Africa (all income levels) and Area (% of total land area) of West Bank and Gaza?
Ensure brevity in your answer.  24.55. In the year 2012, what is the difference between the Area (% of total land area) in Croatia and Area (% of total land area) in West Bank and Gaza?
Your answer should be very brief. 32.8. In the year 2013, what is the difference between the Area (% of total land area) in High income: nonOECD and Area (% of total land area) in Sub-Saharan Africa (all income levels)?
Your response must be concise. 12.67. In the year 2013, what is the difference between the Area (% of total land area) of High income: nonOECD and Area (% of total land area) of Croatia?
Ensure brevity in your answer.  4.29. In the year 2013, what is the difference between the Area (% of total land area) in High income: nonOECD and Area (% of total land area) in West Bank and Gaza?
Offer a terse response. 37.1. In the year 2013, what is the difference between the Area (% of total land area) in Sub-Saharan Africa (all income levels) and Area (% of total land area) in Croatia?
Ensure brevity in your answer.  -8.38. In the year 2013, what is the difference between the Area (% of total land area) of Sub-Saharan Africa (all income levels) and Area (% of total land area) of West Bank and Gaza?
Offer a terse response. 24.43. In the year 2013, what is the difference between the Area (% of total land area) in Croatia and Area (% of total land area) in West Bank and Gaza?
Make the answer very short. 32.81. What is the ratio of the Area (% of total land area) of Sub-Saharan Africa (all income levels) in 2006 to that in 2007?
Give a very brief answer. 1.01. What is the ratio of the Area (% of total land area) of Croatia in 2006 to that in 2007?
Give a very brief answer. 1. What is the ratio of the Area (% of total land area) in Sub-Saharan Africa (all income levels) in 2006 to that in 2008?
Provide a short and direct response. 1.01. What is the ratio of the Area (% of total land area) in Croatia in 2006 to that in 2008?
Give a very brief answer. 1. What is the ratio of the Area (% of total land area) of West Bank and Gaza in 2006 to that in 2008?
Your answer should be very brief. 1. What is the ratio of the Area (% of total land area) of Sub-Saharan Africa (all income levels) in 2006 to that in 2009?
Offer a terse response. 1.02. What is the ratio of the Area (% of total land area) in High income: nonOECD in 2006 to that in 2010?
Provide a short and direct response. 1. What is the ratio of the Area (% of total land area) in Sub-Saharan Africa (all income levels) in 2006 to that in 2010?
Keep it short and to the point. 1.02. What is the ratio of the Area (% of total land area) in Croatia in 2006 to that in 2010?
Provide a short and direct response. 0.99. What is the ratio of the Area (% of total land area) in West Bank and Gaza in 2006 to that in 2010?
Provide a short and direct response. 1. What is the ratio of the Area (% of total land area) of High income: nonOECD in 2006 to that in 2011?
Keep it short and to the point. 1. What is the ratio of the Area (% of total land area) in Sub-Saharan Africa (all income levels) in 2006 to that in 2011?
Ensure brevity in your answer.  1.04. What is the ratio of the Area (% of total land area) of Croatia in 2006 to that in 2011?
Your answer should be compact. 0.99. What is the ratio of the Area (% of total land area) in West Bank and Gaza in 2006 to that in 2011?
Your response must be concise. 1. What is the ratio of the Area (% of total land area) in Sub-Saharan Africa (all income levels) in 2006 to that in 2012?
Your answer should be compact. 1.04. What is the ratio of the Area (% of total land area) of West Bank and Gaza in 2006 to that in 2012?
Offer a terse response. 1. What is the ratio of the Area (% of total land area) of High income: nonOECD in 2006 to that in 2013?
Provide a short and direct response. 1. What is the ratio of the Area (% of total land area) of Sub-Saharan Africa (all income levels) in 2006 to that in 2013?
Your answer should be compact. 1.05. What is the ratio of the Area (% of total land area) of West Bank and Gaza in 2006 to that in 2013?
Offer a terse response. 1. What is the ratio of the Area (% of total land area) of Sub-Saharan Africa (all income levels) in 2007 to that in 2008?
Your answer should be very brief. 1.01. What is the ratio of the Area (% of total land area) in Sub-Saharan Africa (all income levels) in 2007 to that in 2009?
Offer a terse response. 1.01. What is the ratio of the Area (% of total land area) in West Bank and Gaza in 2007 to that in 2009?
Provide a short and direct response. 1. What is the ratio of the Area (% of total land area) in High income: nonOECD in 2007 to that in 2010?
Your response must be concise. 1. What is the ratio of the Area (% of total land area) of Sub-Saharan Africa (all income levels) in 2007 to that in 2010?
Your answer should be very brief. 1.02. What is the ratio of the Area (% of total land area) of Croatia in 2007 to that in 2010?
Provide a succinct answer. 0.99. What is the ratio of the Area (% of total land area) of Sub-Saharan Africa (all income levels) in 2007 to that in 2011?
Offer a very short reply. 1.03. What is the ratio of the Area (% of total land area) of Sub-Saharan Africa (all income levels) in 2007 to that in 2012?
Give a very brief answer. 1.04. What is the ratio of the Area (% of total land area) in West Bank and Gaza in 2007 to that in 2012?
Provide a short and direct response. 1. What is the ratio of the Area (% of total land area) in Sub-Saharan Africa (all income levels) in 2007 to that in 2013?
Offer a terse response. 1.04. What is the ratio of the Area (% of total land area) of Croatia in 2007 to that in 2013?
Keep it short and to the point. 0.99. What is the ratio of the Area (% of total land area) in Sub-Saharan Africa (all income levels) in 2008 to that in 2009?
Offer a very short reply. 1.01. What is the ratio of the Area (% of total land area) of Croatia in 2008 to that in 2009?
Provide a short and direct response. 1. What is the ratio of the Area (% of total land area) in West Bank and Gaza in 2008 to that in 2009?
Make the answer very short. 1. What is the ratio of the Area (% of total land area) in High income: nonOECD in 2008 to that in 2010?
Your response must be concise. 1. What is the ratio of the Area (% of total land area) of Sub-Saharan Africa (all income levels) in 2008 to that in 2010?
Your response must be concise. 1.01. What is the ratio of the Area (% of total land area) of Sub-Saharan Africa (all income levels) in 2008 to that in 2011?
Keep it short and to the point. 1.03. What is the ratio of the Area (% of total land area) of Croatia in 2008 to that in 2011?
Your answer should be compact. 1. What is the ratio of the Area (% of total land area) in West Bank and Gaza in 2008 to that in 2011?
Your answer should be compact. 1. What is the ratio of the Area (% of total land area) of Sub-Saharan Africa (all income levels) in 2008 to that in 2012?
Offer a terse response. 1.03. What is the ratio of the Area (% of total land area) of Sub-Saharan Africa (all income levels) in 2008 to that in 2013?
Provide a short and direct response. 1.04. What is the ratio of the Area (% of total land area) of Croatia in 2008 to that in 2013?
Keep it short and to the point. 1. What is the ratio of the Area (% of total land area) in High income: nonOECD in 2009 to that in 2010?
Your answer should be very brief. 1. What is the ratio of the Area (% of total land area) of Sub-Saharan Africa (all income levels) in 2009 to that in 2010?
Provide a succinct answer. 1.01. What is the ratio of the Area (% of total land area) of High income: nonOECD in 2009 to that in 2011?
Provide a succinct answer. 1. What is the ratio of the Area (% of total land area) of Sub-Saharan Africa (all income levels) in 2009 to that in 2011?
Make the answer very short. 1.02. What is the ratio of the Area (% of total land area) of Croatia in 2009 to that in 2011?
Keep it short and to the point. 1. What is the ratio of the Area (% of total land area) in West Bank and Gaza in 2009 to that in 2011?
Offer a very short reply. 1. What is the ratio of the Area (% of total land area) of Sub-Saharan Africa (all income levels) in 2009 to that in 2012?
Give a very brief answer. 1.03. What is the ratio of the Area (% of total land area) of Croatia in 2009 to that in 2012?
Your answer should be very brief. 1. What is the ratio of the Area (% of total land area) of Sub-Saharan Africa (all income levels) in 2009 to that in 2013?
Provide a short and direct response. 1.03. What is the ratio of the Area (% of total land area) of Sub-Saharan Africa (all income levels) in 2010 to that in 2011?
Ensure brevity in your answer.  1.02. What is the ratio of the Area (% of total land area) in Croatia in 2010 to that in 2011?
Provide a short and direct response. 1. What is the ratio of the Area (% of total land area) in High income: nonOECD in 2010 to that in 2012?
Offer a very short reply. 1. What is the ratio of the Area (% of total land area) of Sub-Saharan Africa (all income levels) in 2010 to that in 2012?
Give a very brief answer. 1.02. What is the ratio of the Area (% of total land area) in Croatia in 2010 to that in 2012?
Make the answer very short. 1. What is the ratio of the Area (% of total land area) in Sub-Saharan Africa (all income levels) in 2010 to that in 2013?
Keep it short and to the point. 1.03. What is the ratio of the Area (% of total land area) in High income: nonOECD in 2011 to that in 2012?
Make the answer very short. 1. What is the ratio of the Area (% of total land area) of Croatia in 2011 to that in 2012?
Keep it short and to the point. 1. What is the ratio of the Area (% of total land area) of West Bank and Gaza in 2011 to that in 2012?
Ensure brevity in your answer.  1. What is the ratio of the Area (% of total land area) of High income: nonOECD in 2011 to that in 2013?
Your response must be concise. 1. What is the ratio of the Area (% of total land area) in Sub-Saharan Africa (all income levels) in 2011 to that in 2013?
Give a very brief answer. 1.01. What is the ratio of the Area (% of total land area) in Croatia in 2011 to that in 2013?
Offer a terse response. 1. What is the ratio of the Area (% of total land area) in West Bank and Gaza in 2011 to that in 2013?
Offer a very short reply. 1. What is the ratio of the Area (% of total land area) in Sub-Saharan Africa (all income levels) in 2012 to that in 2013?
Provide a succinct answer. 1. What is the ratio of the Area (% of total land area) of Croatia in 2012 to that in 2013?
Provide a succinct answer. 1. What is the difference between the highest and the second highest Area (% of total land area) in High income: nonOECD?
Give a very brief answer. 0.02. What is the difference between the highest and the second highest Area (% of total land area) of Sub-Saharan Africa (all income levels)?
Give a very brief answer. 0.15. What is the difference between the highest and the second highest Area (% of total land area) in Croatia?
Give a very brief answer. 0.01. What is the difference between the highest and the second highest Area (% of total land area) in West Bank and Gaza?
Your response must be concise. 0. What is the difference between the highest and the lowest Area (% of total land area) in High income: nonOECD?
Provide a short and direct response. 0.17. What is the difference between the highest and the lowest Area (% of total land area) in Sub-Saharan Africa (all income levels)?
Provide a short and direct response. 1.25. What is the difference between the highest and the lowest Area (% of total land area) in Croatia?
Your response must be concise. 0.26. What is the difference between the highest and the lowest Area (% of total land area) of West Bank and Gaza?
Provide a short and direct response. 0. 